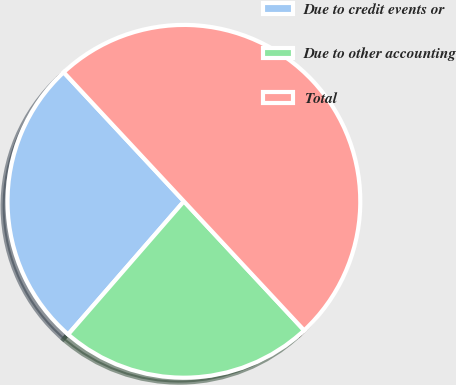<chart> <loc_0><loc_0><loc_500><loc_500><pie_chart><fcel>Due to credit events or<fcel>Due to other accounting<fcel>Total<nl><fcel>26.67%<fcel>23.33%<fcel>50.0%<nl></chart> 